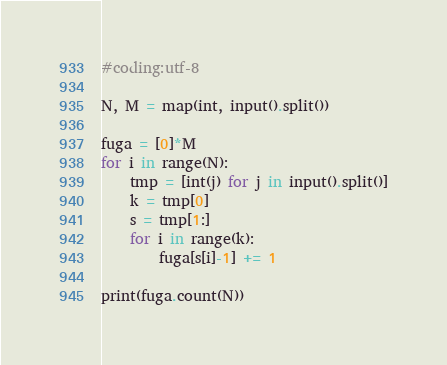<code> <loc_0><loc_0><loc_500><loc_500><_Python_>#coding:utf-8

N, M = map(int, input().split())

fuga = [0]*M
for i in range(N):
    tmp = [int(j) for j in input().split()]
    k = tmp[0]
    s = tmp[1:]
    for i in range(k):
        fuga[s[i]-1] += 1

print(fuga.count(N))
</code> 